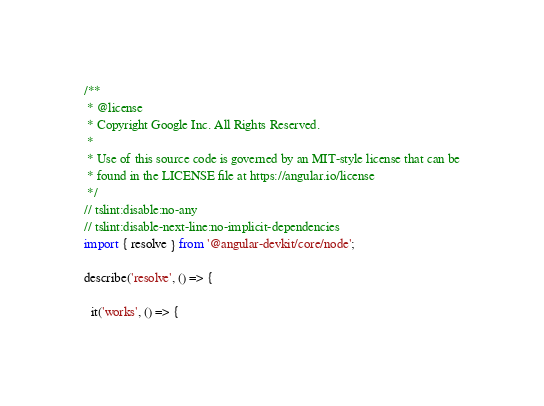Convert code to text. <code><loc_0><loc_0><loc_500><loc_500><_TypeScript_>/**
 * @license
 * Copyright Google Inc. All Rights Reserved.
 *
 * Use of this source code is governed by an MIT-style license that can be
 * found in the LICENSE file at https://angular.io/license
 */
// tslint:disable:no-any
// tslint:disable-next-line:no-implicit-dependencies
import { resolve } from '@angular-devkit/core/node';

describe('resolve', () => {

  it('works', () => {</code> 